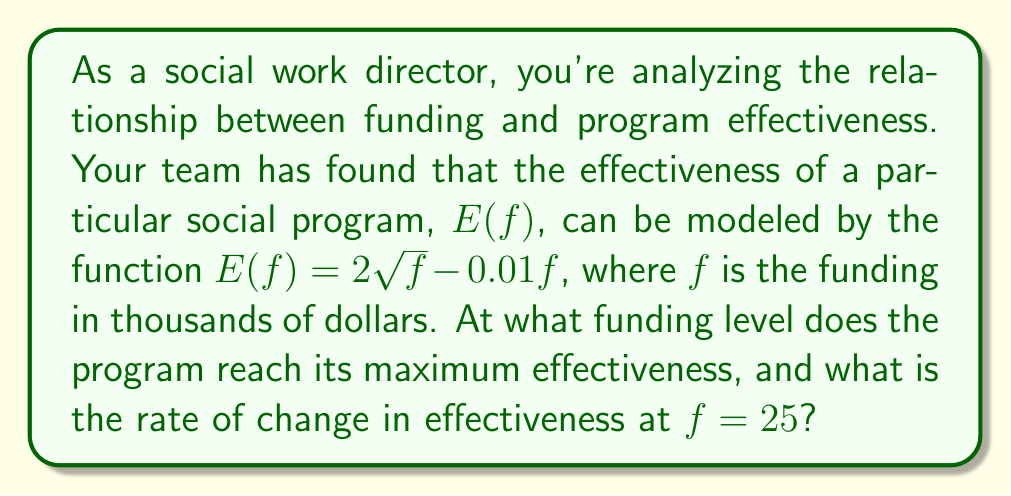Give your solution to this math problem. To solve this problem, we need to use calculus concepts, specifically derivatives.

Step 1: Find the derivative of the effectiveness function.
$$E(f) = 2\sqrt{f} - 0.01f$$
$$E'(f) = \frac{1}{\sqrt{f}} - 0.01$$

Step 2: To find the maximum effectiveness, set the derivative to zero and solve for f.
$$E'(f) = 0$$
$$\frac{1}{\sqrt{f}} - 0.01 = 0$$
$$\frac{1}{\sqrt{f}} = 0.01$$
$$\sqrt{f} = 100$$
$$f = 10,000$$

This means the program reaches its maximum effectiveness at a funding level of $10,000 thousand dollars, or $10 million.

Step 3: To find the rate of change in effectiveness at $f = 25$, we simply need to evaluate the derivative at this point.
$$E'(25) = \frac{1}{\sqrt{25}} - 0.01$$
$$E'(25) = \frac{1}{5} - 0.01$$
$$E'(25) = 0.2 - 0.01 = 0.19$$

This means that at a funding level of $25,000, the rate of change in effectiveness is 0.19 units per thousand dollars.
Answer: Maximum effectiveness at $f = 10,000$; Rate of change at $f = 25$ is $0.19$ 